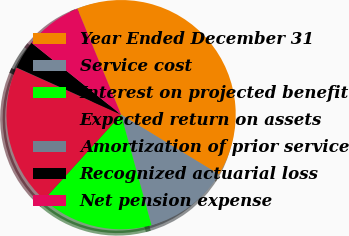Convert chart. <chart><loc_0><loc_0><loc_500><loc_500><pie_chart><fcel>Year Ended December 31<fcel>Service cost<fcel>Interest on projected benefit<fcel>Expected return on assets<fcel>Amortization of prior service<fcel>Recognized actuarial loss<fcel>Net pension expense<nl><fcel>39.96%<fcel>12.0%<fcel>16.0%<fcel>19.99%<fcel>0.02%<fcel>4.02%<fcel>8.01%<nl></chart> 